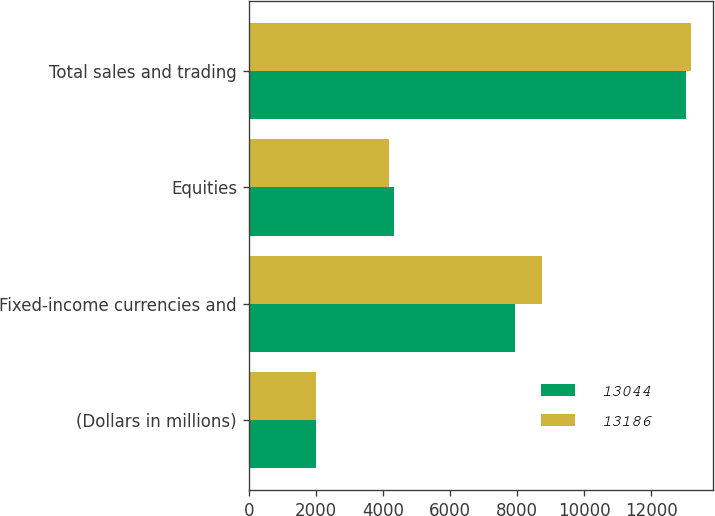Convert chart to OTSL. <chart><loc_0><loc_0><loc_500><loc_500><stacked_bar_chart><ecel><fcel>(Dollars in millions)<fcel>Fixed-income currencies and<fcel>Equities<fcel>Total sales and trading<nl><fcel>13044<fcel>2015<fcel>7923<fcel>4335<fcel>13044<nl><fcel>13186<fcel>2014<fcel>8752<fcel>4194<fcel>13186<nl></chart> 